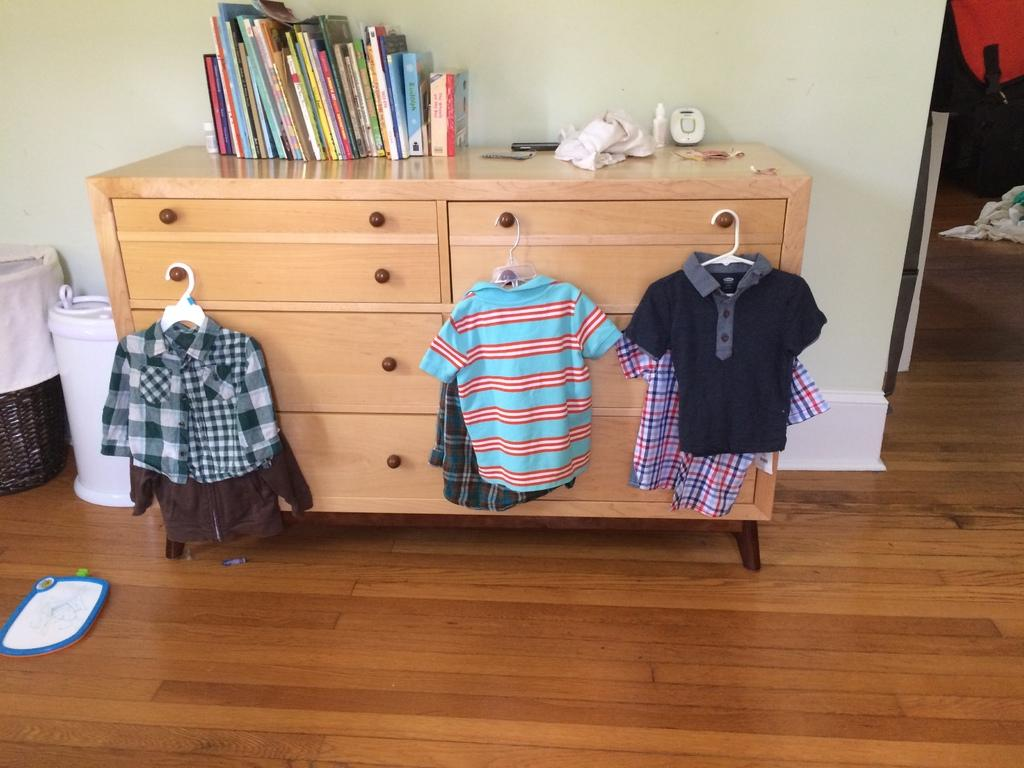What is the main object in the image? There is a table with racks in the image. What is being stored on the table? Clothes are hung on the racks, and there are books, a cloth, a bottle, and a basket on the table. What can be seen in the background of the image? There is a wall visible in the background of the image. How does the zephyr affect the clothes hanging on the racks in the image? There is no zephyr present in the image, so its effect on the clothes cannot be determined. 